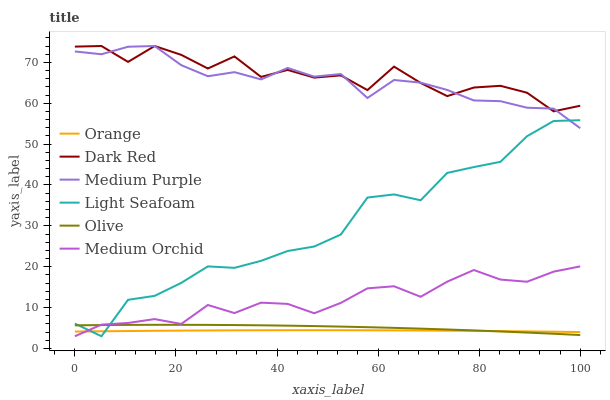Does Orange have the minimum area under the curve?
Answer yes or no. Yes. Does Dark Red have the maximum area under the curve?
Answer yes or no. Yes. Does Medium Orchid have the minimum area under the curve?
Answer yes or no. No. Does Medium Orchid have the maximum area under the curve?
Answer yes or no. No. Is Orange the smoothest?
Answer yes or no. Yes. Is Dark Red the roughest?
Answer yes or no. Yes. Is Medium Orchid the smoothest?
Answer yes or no. No. Is Medium Orchid the roughest?
Answer yes or no. No. Does Medium Purple have the lowest value?
Answer yes or no. No. Does Medium Orchid have the highest value?
Answer yes or no. No. Is Orange less than Dark Red?
Answer yes or no. Yes. Is Medium Purple greater than Olive?
Answer yes or no. Yes. Does Orange intersect Dark Red?
Answer yes or no. No. 